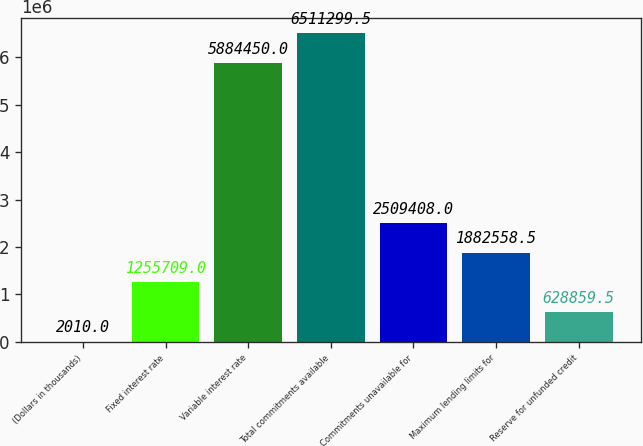Convert chart. <chart><loc_0><loc_0><loc_500><loc_500><bar_chart><fcel>(Dollars in thousands)<fcel>Fixed interest rate<fcel>Variable interest rate<fcel>Total commitments available<fcel>Commitments unavailable for<fcel>Maximum lending limits for<fcel>Reserve for unfunded credit<nl><fcel>2010<fcel>1.25571e+06<fcel>5.88445e+06<fcel>6.5113e+06<fcel>2.50941e+06<fcel>1.88256e+06<fcel>628860<nl></chart> 